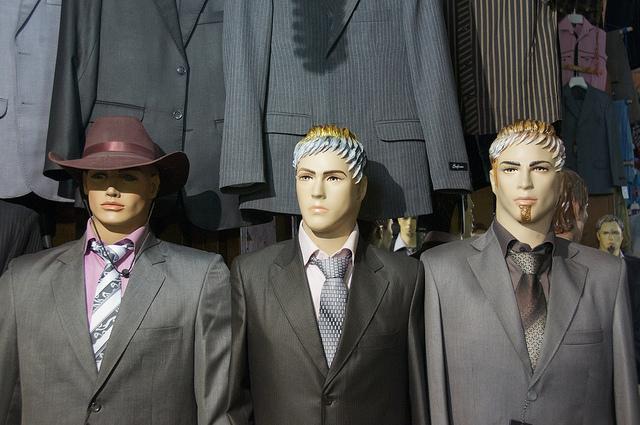How many hats?
Give a very brief answer. 1. Do all the models have ties?
Quick response, please. Yes. Are these living people?
Be succinct. No. 